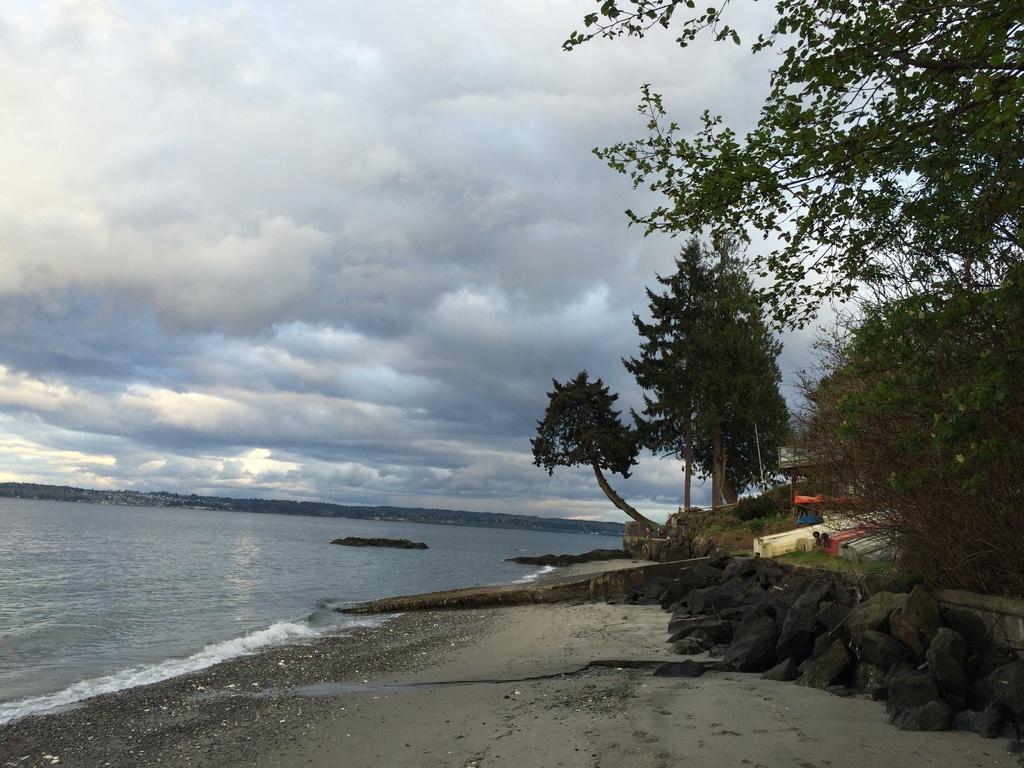Please provide a concise description of this image. This image is taken outdoors. At the top of the image there is a sky with clouds. At the bottom of the image there is a ground. On the left side of the image there is a sea. On the right side of the image there are a few trees and plants on the ground. There are a few rocks. 